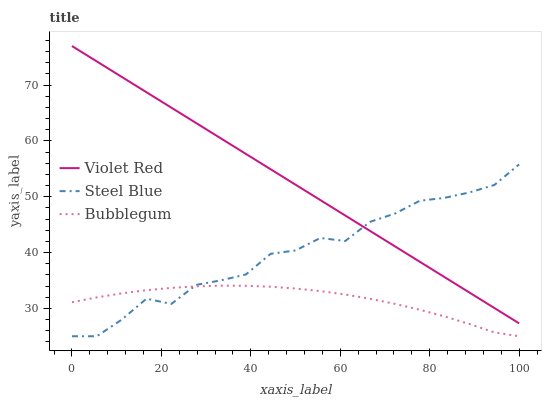Does Bubblegum have the minimum area under the curve?
Answer yes or no. Yes. Does Violet Red have the maximum area under the curve?
Answer yes or no. Yes. Does Steel Blue have the minimum area under the curve?
Answer yes or no. No. Does Steel Blue have the maximum area under the curve?
Answer yes or no. No. Is Violet Red the smoothest?
Answer yes or no. Yes. Is Steel Blue the roughest?
Answer yes or no. Yes. Is Bubblegum the smoothest?
Answer yes or no. No. Is Bubblegum the roughest?
Answer yes or no. No. Does Steel Blue have the lowest value?
Answer yes or no. Yes. Does Violet Red have the highest value?
Answer yes or no. Yes. Does Steel Blue have the highest value?
Answer yes or no. No. Is Bubblegum less than Violet Red?
Answer yes or no. Yes. Is Violet Red greater than Bubblegum?
Answer yes or no. Yes. Does Steel Blue intersect Violet Red?
Answer yes or no. Yes. Is Steel Blue less than Violet Red?
Answer yes or no. No. Is Steel Blue greater than Violet Red?
Answer yes or no. No. Does Bubblegum intersect Violet Red?
Answer yes or no. No. 